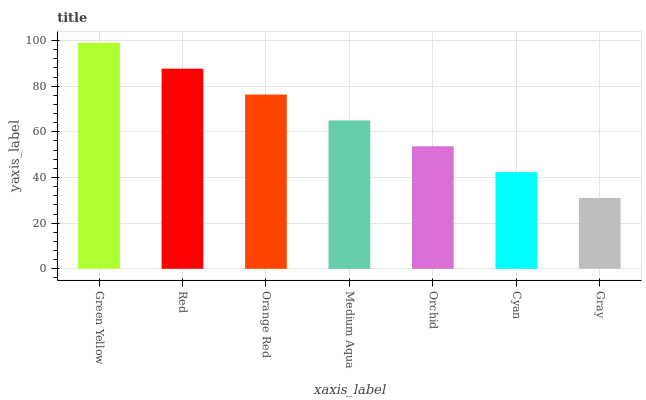Is Gray the minimum?
Answer yes or no. Yes. Is Green Yellow the maximum?
Answer yes or no. Yes. Is Red the minimum?
Answer yes or no. No. Is Red the maximum?
Answer yes or no. No. Is Green Yellow greater than Red?
Answer yes or no. Yes. Is Red less than Green Yellow?
Answer yes or no. Yes. Is Red greater than Green Yellow?
Answer yes or no. No. Is Green Yellow less than Red?
Answer yes or no. No. Is Medium Aqua the high median?
Answer yes or no. Yes. Is Medium Aqua the low median?
Answer yes or no. Yes. Is Gray the high median?
Answer yes or no. No. Is Green Yellow the low median?
Answer yes or no. No. 